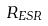<formula> <loc_0><loc_0><loc_500><loc_500>R _ { E S R }</formula> 